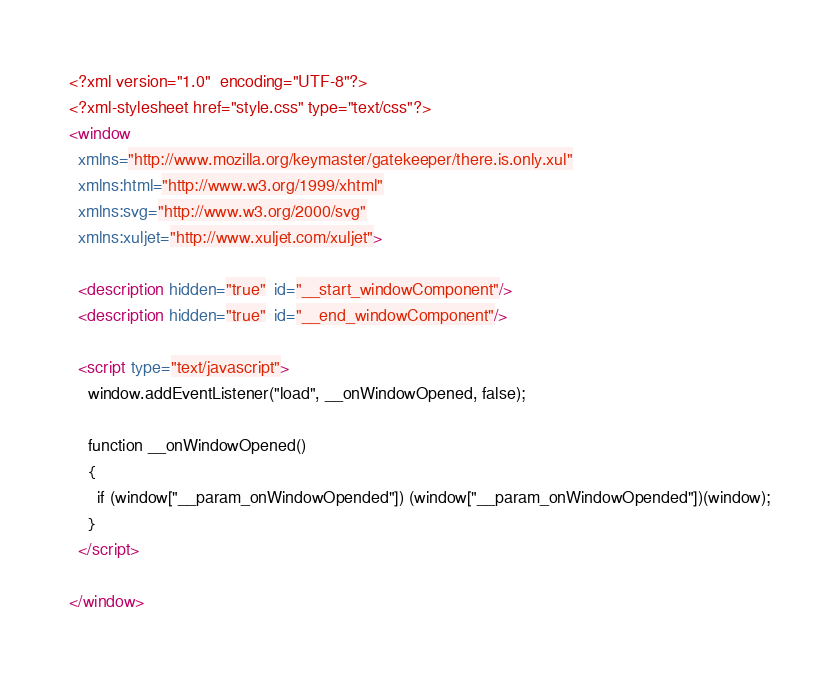<code> <loc_0><loc_0><loc_500><loc_500><_XML_><?xml version="1.0"  encoding="UTF-8"?><?xml-stylesheet href="style.css" type="text/css"?><window   xmlns="http://www.mozilla.org/keymaster/gatekeeper/there.is.only.xul"  xmlns:html="http://www.w3.org/1999/xhtml"   xmlns:svg="http://www.w3.org/2000/svg"   xmlns:xuljet="http://www.xuljet.com/xuljet">  <description hidden="true"  id="__start_windowComponent"/>  <description hidden="true"  id="__end_windowComponent"/>  <script type="text/javascript">    window.addEventListener("load", __onWindowOpened, false);		function __onWindowOpened()	{	  if (window["__param_onWindowOpended"]) (window["__param_onWindowOpended"])(window);	}  </script>	</window></code> 